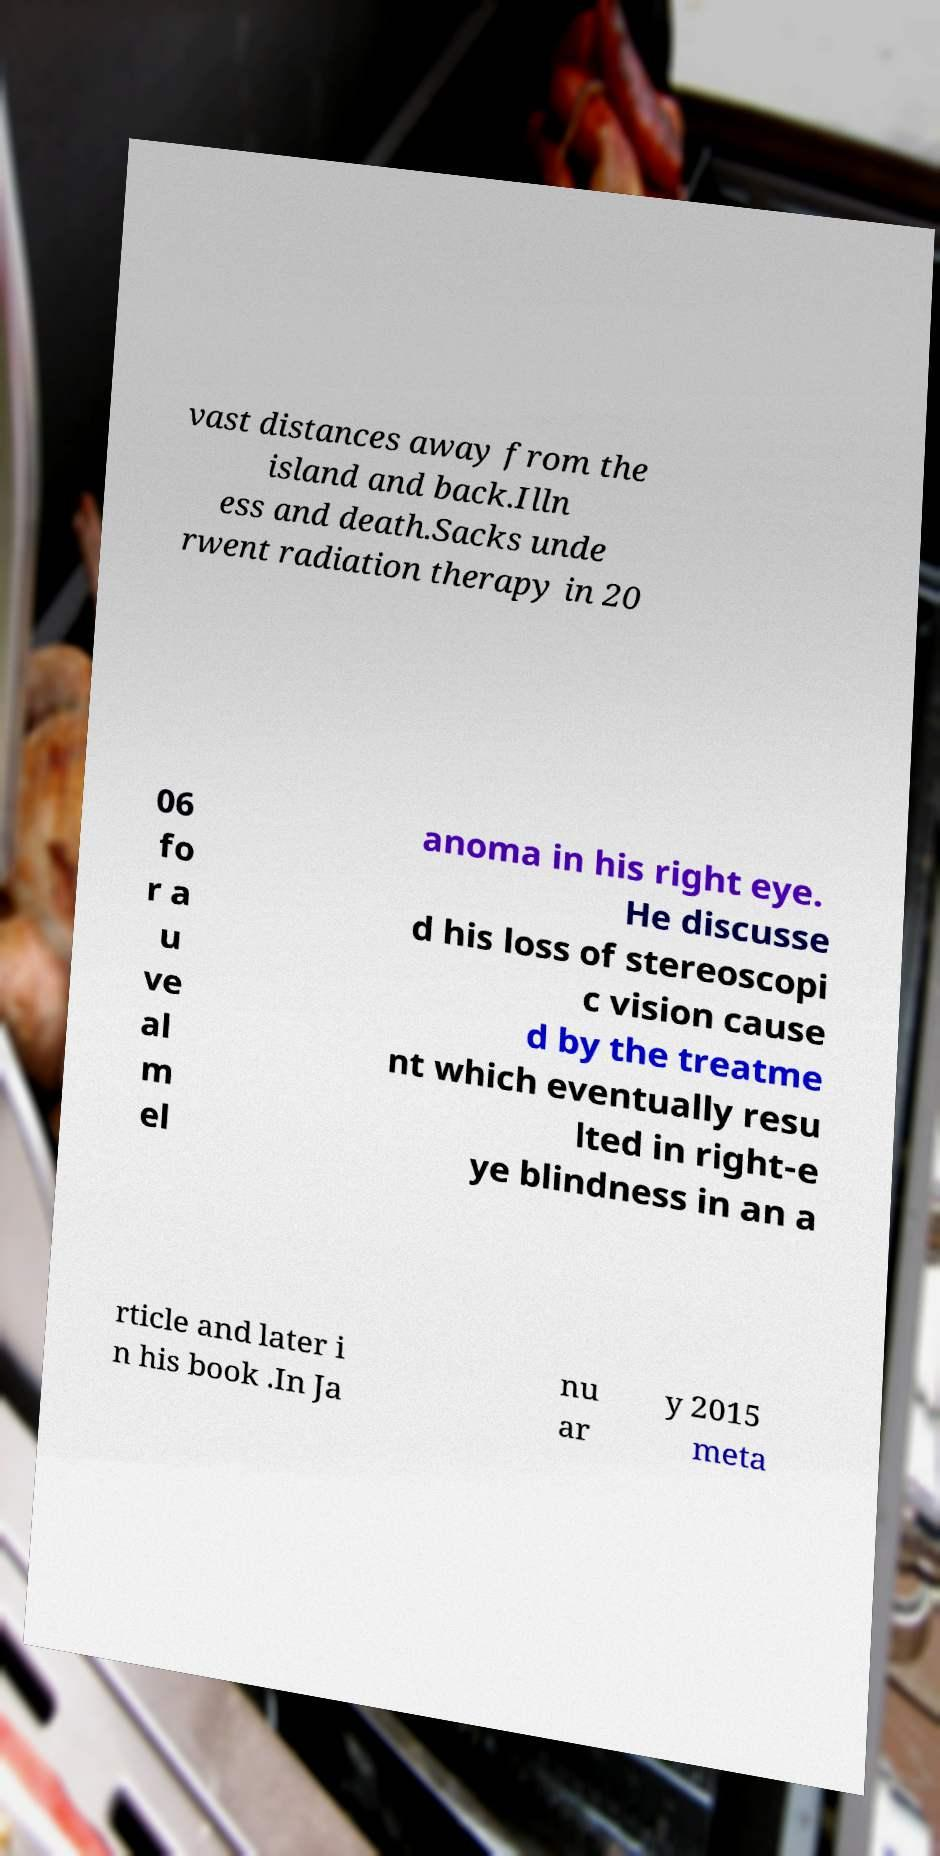Please read and relay the text visible in this image. What does it say? vast distances away from the island and back.Illn ess and death.Sacks unde rwent radiation therapy in 20 06 fo r a u ve al m el anoma in his right eye. He discusse d his loss of stereoscopi c vision cause d by the treatme nt which eventually resu lted in right-e ye blindness in an a rticle and later i n his book .In Ja nu ar y 2015 meta 